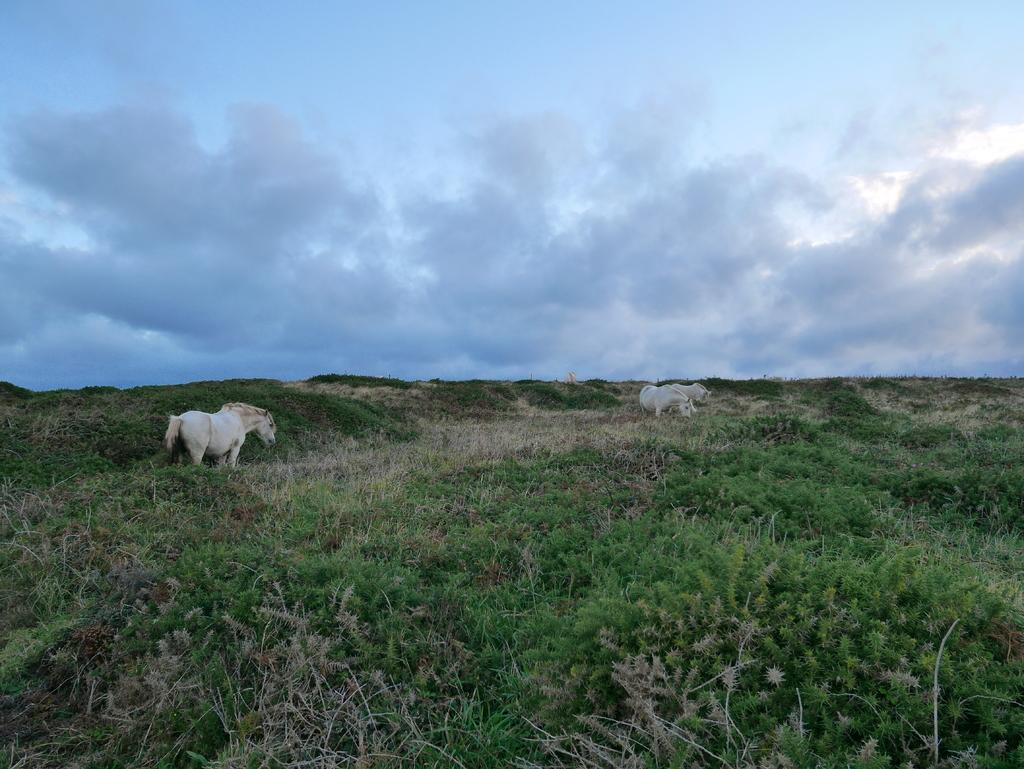What types of living organisms can be seen in the image? There are animals in the image. What is the ground surface like in the image? The ground in the image is covered with grass. What can be seen in the sky in the image? There are clouds in the sky in the image. What type of rhythm can be heard from the animals in the image? There is no sound or rhythm present in the image; it is a still image of animals on grass with clouds in the sky. 